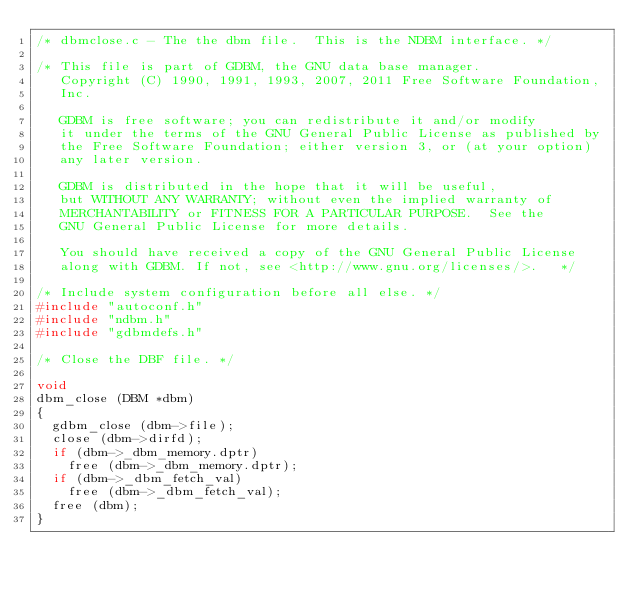<code> <loc_0><loc_0><loc_500><loc_500><_C_>/* dbmclose.c - The the dbm file.  This is the NDBM interface. */

/* This file is part of GDBM, the GNU data base manager.
   Copyright (C) 1990, 1991, 1993, 2007, 2011 Free Software Foundation,
   Inc.

   GDBM is free software; you can redistribute it and/or modify
   it under the terms of the GNU General Public License as published by
   the Free Software Foundation; either version 3, or (at your option)
   any later version.

   GDBM is distributed in the hope that it will be useful,
   but WITHOUT ANY WARRANTY; without even the implied warranty of
   MERCHANTABILITY or FITNESS FOR A PARTICULAR PURPOSE.  See the
   GNU General Public License for more details.

   You should have received a copy of the GNU General Public License
   along with GDBM. If not, see <http://www.gnu.org/licenses/>.   */

/* Include system configuration before all else. */
#include "autoconf.h"
#include "ndbm.h"
#include "gdbmdefs.h"

/* Close the DBF file. */

void
dbm_close (DBM *dbm)
{
  gdbm_close (dbm->file);
  close (dbm->dirfd);
  if (dbm->_dbm_memory.dptr)
    free (dbm->_dbm_memory.dptr);
  if (dbm->_dbm_fetch_val)
    free (dbm->_dbm_fetch_val);
  free (dbm);
}
</code> 